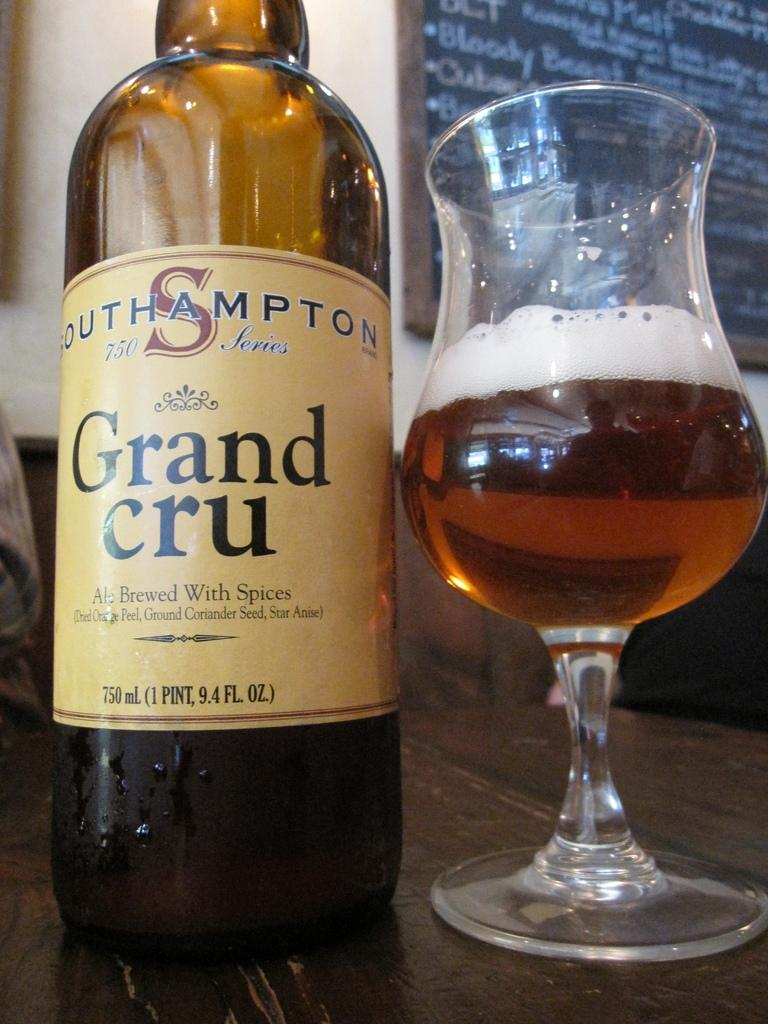<image>
Present a compact description of the photo's key features. A 750 milliliter bottle of Grand Cru and a glass of beer rest on a wooden surface. 